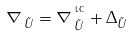<formula> <loc_0><loc_0><loc_500><loc_500>\nabla _ { \, \tilde { U } } = \nabla _ { \, \tilde { U } } ^ { ^ { \text { LC} } } + \Delta _ { \tilde { U } }</formula> 